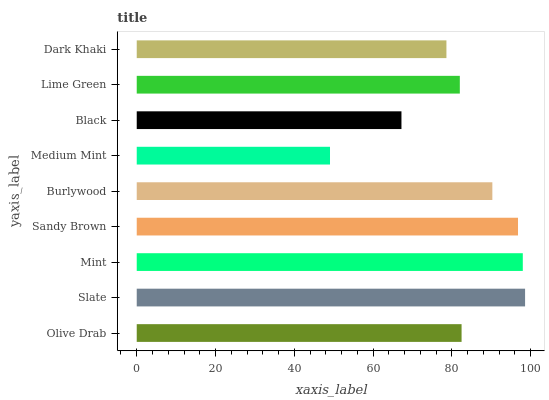Is Medium Mint the minimum?
Answer yes or no. Yes. Is Slate the maximum?
Answer yes or no. Yes. Is Mint the minimum?
Answer yes or no. No. Is Mint the maximum?
Answer yes or no. No. Is Slate greater than Mint?
Answer yes or no. Yes. Is Mint less than Slate?
Answer yes or no. Yes. Is Mint greater than Slate?
Answer yes or no. No. Is Slate less than Mint?
Answer yes or no. No. Is Olive Drab the high median?
Answer yes or no. Yes. Is Olive Drab the low median?
Answer yes or no. Yes. Is Medium Mint the high median?
Answer yes or no. No. Is Black the low median?
Answer yes or no. No. 